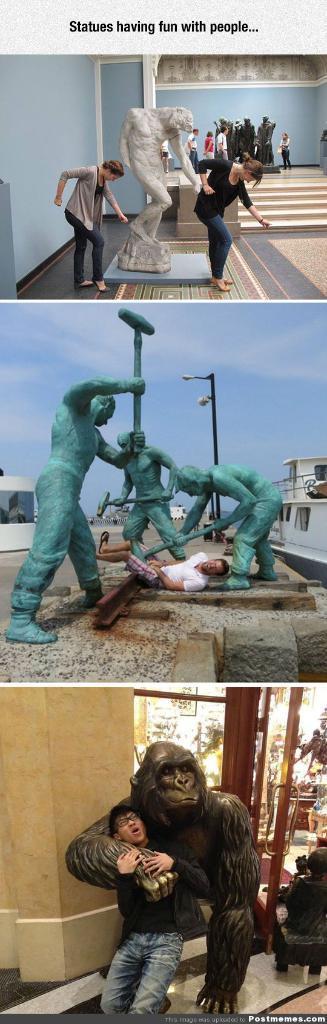Please provide a concise description of this image. This is a photo collage, we can see some statues and people in the photos. 